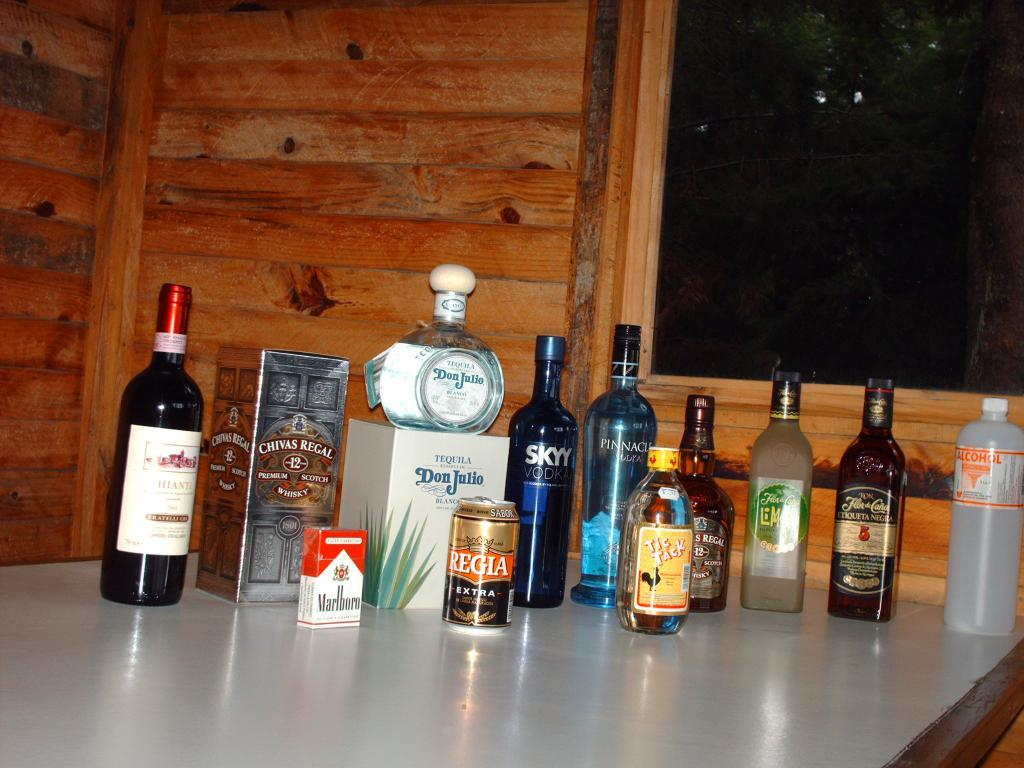<image>
Present a compact description of the photo's key features. Several bottles and cans lined up on a table with a pack of Marlboro cigarettes. 